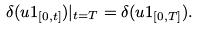<formula> <loc_0><loc_0><loc_500><loc_500>\delta ( u 1 _ { [ 0 , t ] } ) | _ { t = T } = \delta ( u 1 _ { [ 0 , T ] } ) .</formula> 